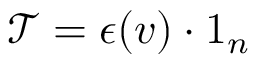Convert formula to latex. <formula><loc_0><loc_0><loc_500><loc_500>\mathcal { T } = \epsilon ( v ) \cdot 1 _ { n }</formula> 